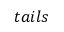Convert formula to latex. <formula><loc_0><loc_0><loc_500><loc_500>t a i l s</formula> 